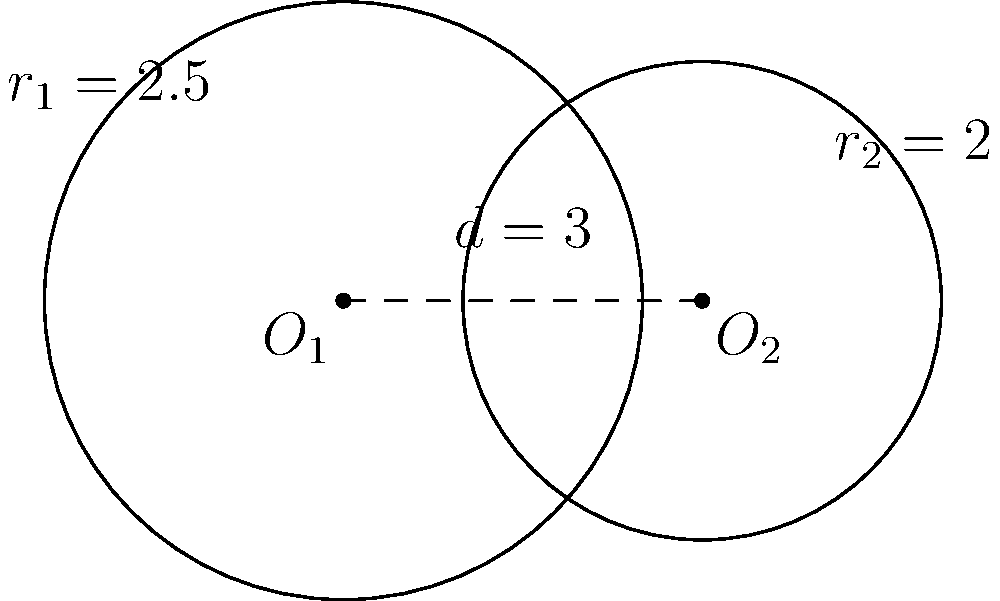As a data scientist working with geospatial data in MongoDB, you encounter a problem involving overlapping circular regions. Two circles are given: Circle 1 with center $O_1(0,0)$ and radius $r_1=2.5$, and Circle 2 with center $O_2(3,0)$ and radius $r_2=2$. Calculate the area of the overlapping region between these two circles. To solve this problem, we'll follow these steps:

1) First, we need to determine if the circles intersect. The distance between centers is $d=3$, and $r_1 + r_2 = 4.5 > d$, so they do intersect.

2) The area of overlap for two intersecting circles is given by the formula:

   $$A = r_1^2 \arccos(\frac{d^2 + r_1^2 - r_2^2}{2dr_1}) + r_2^2 \arccos(\frac{d^2 + r_2^2 - r_1^2}{2dr_2}) - \frac{1}{2}\sqrt{(-d+r_1+r_2)(d+r_1-r_2)(d-r_1+r_2)(d+r_1+r_2)}$$

3) Let's substitute our values:
   $r_1 = 2.5$, $r_2 = 2$, $d = 3$

4) Calculate each part:
   
   $\arccos(\frac{3^2 + 2.5^2 - 2^2}{2 * 3 * 2.5}) = 0.7297$
   
   $\arccos(\frac{3^2 + 2^2 - 2.5^2}{2 * 3 * 2}) = 1.0472$
   
   $\sqrt{(-3+2.5+2)(3+2.5-2)(3-2.5+2)(3+2.5+2)} = 3.7417$

5) Putting it all together:

   $A = 2.5^2 * 0.7297 + 2^2 * 1.0472 - \frac{1}{2} * 3.7417$
   
   $A = 4.5606 + 4.1888 - 1.8708$
   
   $A = 6.8786$

Therefore, the area of overlap is approximately 6.8786 square units.
Answer: 6.8786 square units 